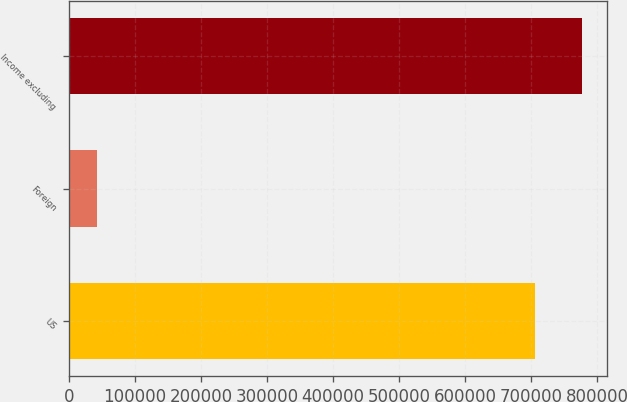Convert chart to OTSL. <chart><loc_0><loc_0><loc_500><loc_500><bar_chart><fcel>US<fcel>Foreign<fcel>Income excluding<nl><fcel>705878<fcel>42167<fcel>776466<nl></chart> 